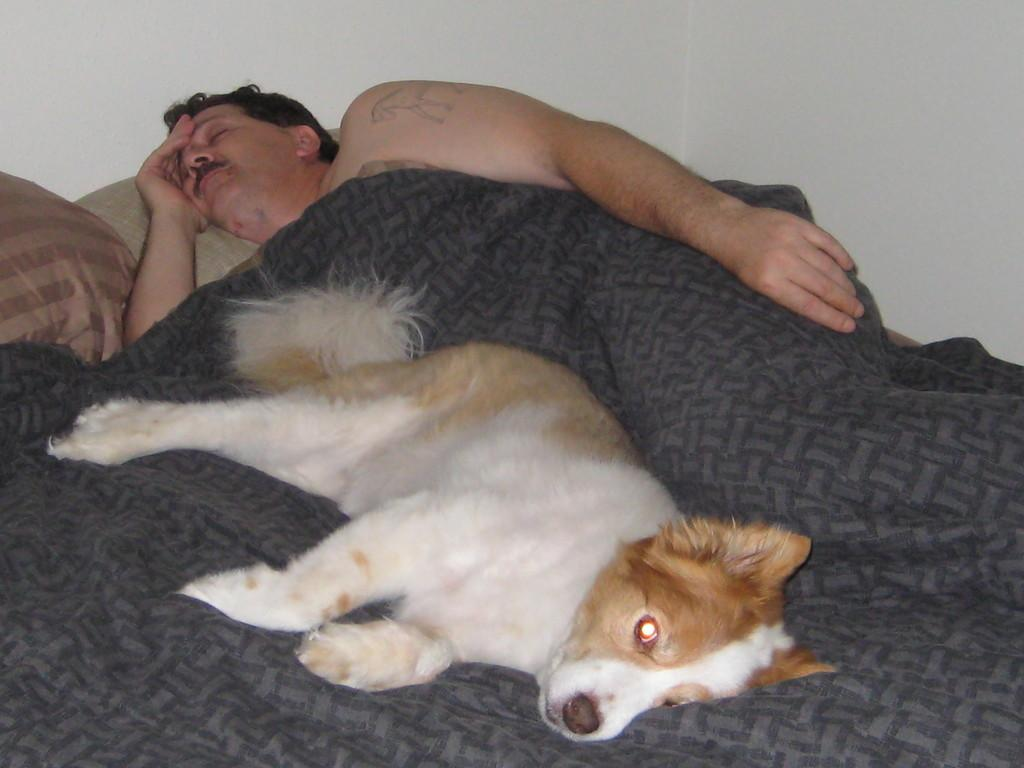What objects can be seen on the bed in the image? There are pillows and a blanket on the bed. What is the person on the bed doing? The person is sleeping on the bed. Is there any other living creature on the bed? Yes, there is a dog on the bed. What can be seen in the background of the image? A wall is visible in the background. What type of nerve can be seen in the image? There is no nerve present in the image. Is there any soda visible in the image? There is no soda present in the image. 